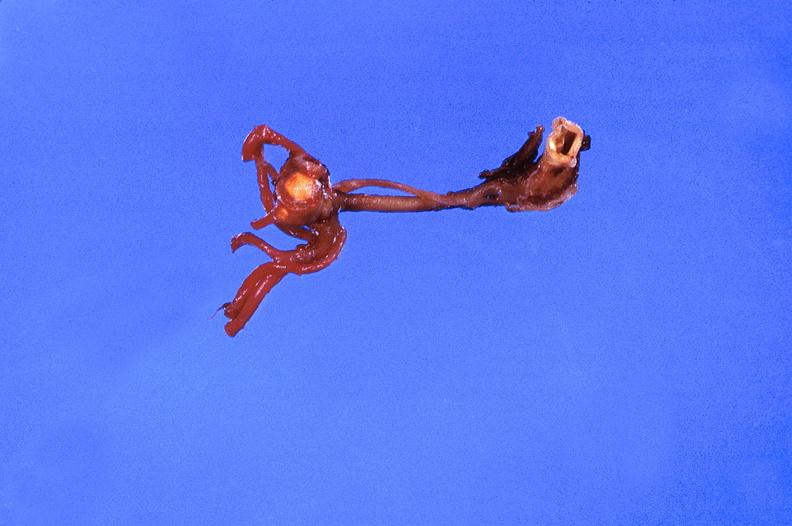s metastatic carcinoma prostate present?
Answer the question using a single word or phrase. No 